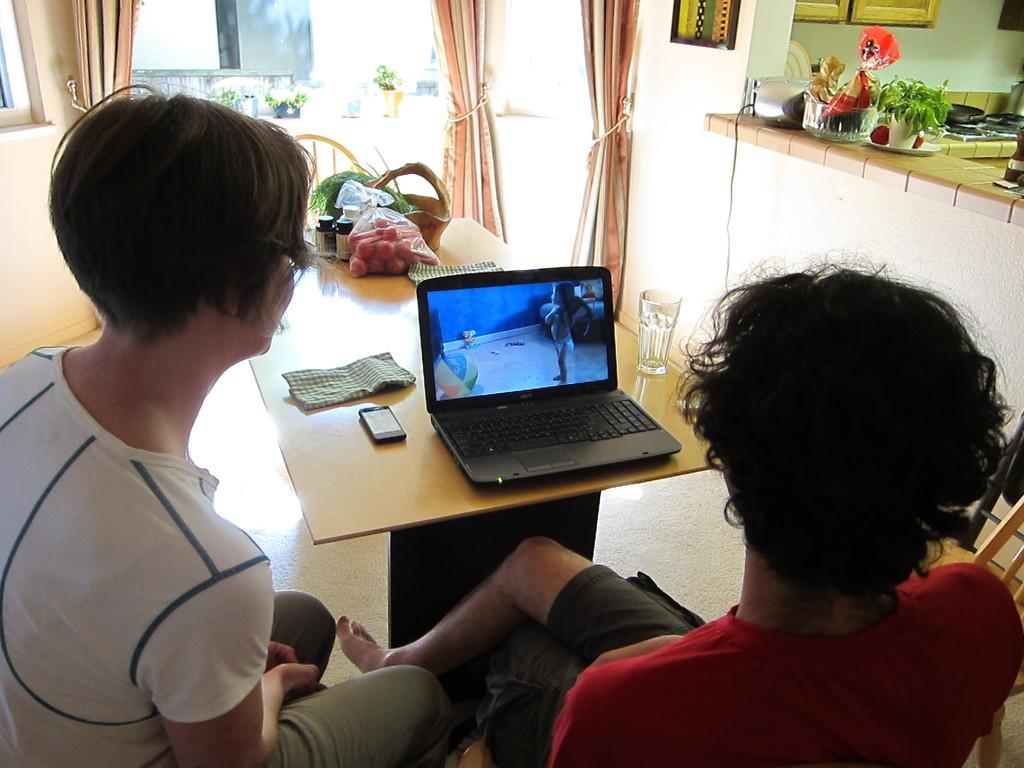How would you summarize this image in a sentence or two? The picture consists of a room in which there are two people sitting on the chairs and in front of them there is one table and on the table one laptop, mobile, napkins, fruits, basket and some glasses are present and at the right corner there is one countertop on which some groceries are present and one stove and a pan on it and there are curtains and some flowers plants outside of the room. 